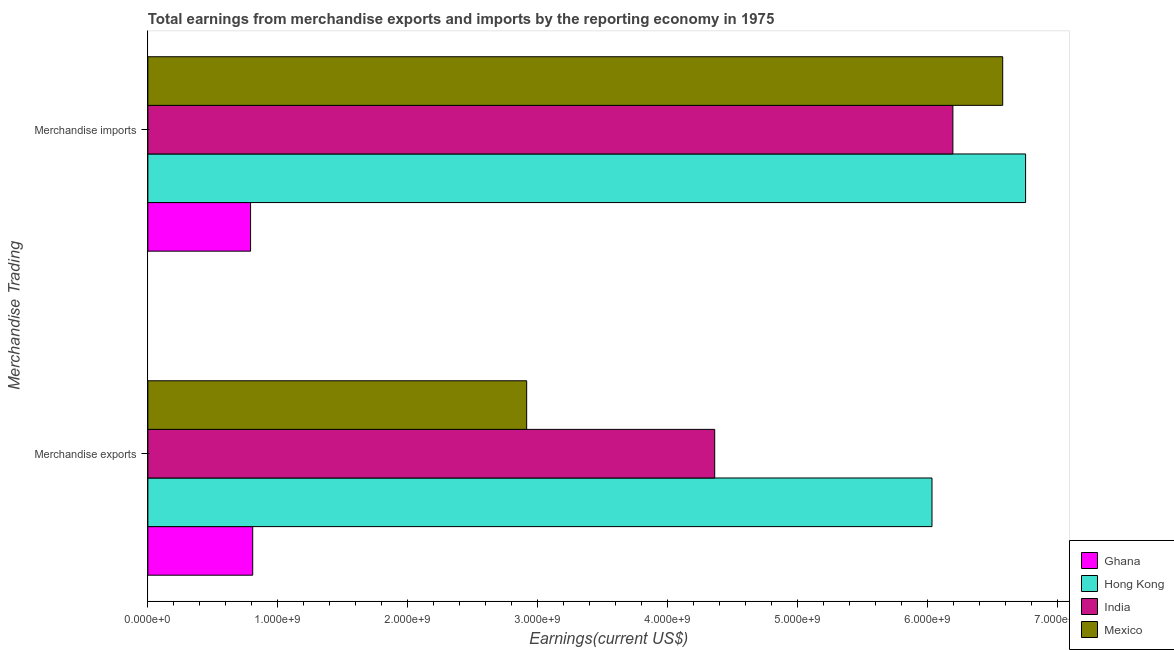How many groups of bars are there?
Make the answer very short. 2. Are the number of bars per tick equal to the number of legend labels?
Offer a terse response. Yes. Are the number of bars on each tick of the Y-axis equal?
Offer a terse response. Yes. How many bars are there on the 2nd tick from the top?
Your answer should be compact. 4. How many bars are there on the 1st tick from the bottom?
Ensure brevity in your answer.  4. What is the earnings from merchandise imports in Hong Kong?
Ensure brevity in your answer.  6.76e+09. Across all countries, what is the maximum earnings from merchandise imports?
Your response must be concise. 6.76e+09. Across all countries, what is the minimum earnings from merchandise exports?
Provide a succinct answer. 8.07e+08. In which country was the earnings from merchandise exports maximum?
Your answer should be compact. Hong Kong. What is the total earnings from merchandise imports in the graph?
Your answer should be very brief. 2.03e+1. What is the difference between the earnings from merchandise exports in Hong Kong and that in India?
Keep it short and to the point. 1.67e+09. What is the difference between the earnings from merchandise imports in Hong Kong and the earnings from merchandise exports in India?
Keep it short and to the point. 2.39e+09. What is the average earnings from merchandise exports per country?
Provide a succinct answer. 3.53e+09. What is the difference between the earnings from merchandise exports and earnings from merchandise imports in India?
Give a very brief answer. -1.83e+09. What is the ratio of the earnings from merchandise exports in Mexico to that in India?
Offer a terse response. 0.67. In how many countries, is the earnings from merchandise exports greater than the average earnings from merchandise exports taken over all countries?
Give a very brief answer. 2. What does the 1st bar from the top in Merchandise imports represents?
Offer a terse response. Mexico. What does the 1st bar from the bottom in Merchandise imports represents?
Ensure brevity in your answer.  Ghana. Are all the bars in the graph horizontal?
Your response must be concise. Yes. Does the graph contain grids?
Your answer should be compact. No. How many legend labels are there?
Ensure brevity in your answer.  4. How are the legend labels stacked?
Provide a short and direct response. Vertical. What is the title of the graph?
Provide a succinct answer. Total earnings from merchandise exports and imports by the reporting economy in 1975. Does "Middle East & North Africa (all income levels)" appear as one of the legend labels in the graph?
Ensure brevity in your answer.  No. What is the label or title of the X-axis?
Give a very brief answer. Earnings(current US$). What is the label or title of the Y-axis?
Provide a succinct answer. Merchandise Trading. What is the Earnings(current US$) in Ghana in Merchandise exports?
Your response must be concise. 8.07e+08. What is the Earnings(current US$) of Hong Kong in Merchandise exports?
Provide a succinct answer. 6.04e+09. What is the Earnings(current US$) of India in Merchandise exports?
Your response must be concise. 4.36e+09. What is the Earnings(current US$) of Mexico in Merchandise exports?
Ensure brevity in your answer.  2.92e+09. What is the Earnings(current US$) of Ghana in Merchandise imports?
Your answer should be compact. 7.91e+08. What is the Earnings(current US$) of Hong Kong in Merchandise imports?
Your answer should be compact. 6.76e+09. What is the Earnings(current US$) of India in Merchandise imports?
Provide a succinct answer. 6.20e+09. What is the Earnings(current US$) in Mexico in Merchandise imports?
Provide a short and direct response. 6.58e+09. Across all Merchandise Trading, what is the maximum Earnings(current US$) in Ghana?
Provide a succinct answer. 8.07e+08. Across all Merchandise Trading, what is the maximum Earnings(current US$) of Hong Kong?
Your answer should be very brief. 6.76e+09. Across all Merchandise Trading, what is the maximum Earnings(current US$) in India?
Keep it short and to the point. 6.20e+09. Across all Merchandise Trading, what is the maximum Earnings(current US$) in Mexico?
Your answer should be compact. 6.58e+09. Across all Merchandise Trading, what is the minimum Earnings(current US$) in Ghana?
Your answer should be compact. 7.91e+08. Across all Merchandise Trading, what is the minimum Earnings(current US$) of Hong Kong?
Make the answer very short. 6.04e+09. Across all Merchandise Trading, what is the minimum Earnings(current US$) in India?
Offer a terse response. 4.36e+09. Across all Merchandise Trading, what is the minimum Earnings(current US$) of Mexico?
Keep it short and to the point. 2.92e+09. What is the total Earnings(current US$) of Ghana in the graph?
Make the answer very short. 1.60e+09. What is the total Earnings(current US$) in Hong Kong in the graph?
Provide a short and direct response. 1.28e+1. What is the total Earnings(current US$) of India in the graph?
Your answer should be compact. 1.06e+1. What is the total Earnings(current US$) of Mexico in the graph?
Give a very brief answer. 9.50e+09. What is the difference between the Earnings(current US$) in Ghana in Merchandise exports and that in Merchandise imports?
Offer a very short reply. 1.65e+07. What is the difference between the Earnings(current US$) of Hong Kong in Merchandise exports and that in Merchandise imports?
Ensure brevity in your answer.  -7.21e+08. What is the difference between the Earnings(current US$) in India in Merchandise exports and that in Merchandise imports?
Give a very brief answer. -1.83e+09. What is the difference between the Earnings(current US$) of Mexico in Merchandise exports and that in Merchandise imports?
Your response must be concise. -3.66e+09. What is the difference between the Earnings(current US$) of Ghana in Merchandise exports and the Earnings(current US$) of Hong Kong in Merchandise imports?
Provide a succinct answer. -5.95e+09. What is the difference between the Earnings(current US$) of Ghana in Merchandise exports and the Earnings(current US$) of India in Merchandise imports?
Your response must be concise. -5.39e+09. What is the difference between the Earnings(current US$) of Ghana in Merchandise exports and the Earnings(current US$) of Mexico in Merchandise imports?
Your answer should be very brief. -5.77e+09. What is the difference between the Earnings(current US$) of Hong Kong in Merchandise exports and the Earnings(current US$) of India in Merchandise imports?
Offer a terse response. -1.61e+08. What is the difference between the Earnings(current US$) in Hong Kong in Merchandise exports and the Earnings(current US$) in Mexico in Merchandise imports?
Make the answer very short. -5.44e+08. What is the difference between the Earnings(current US$) of India in Merchandise exports and the Earnings(current US$) of Mexico in Merchandise imports?
Ensure brevity in your answer.  -2.22e+09. What is the average Earnings(current US$) in Ghana per Merchandise Trading?
Your answer should be very brief. 7.99e+08. What is the average Earnings(current US$) in Hong Kong per Merchandise Trading?
Your response must be concise. 6.40e+09. What is the average Earnings(current US$) of India per Merchandise Trading?
Provide a short and direct response. 5.28e+09. What is the average Earnings(current US$) of Mexico per Merchandise Trading?
Provide a short and direct response. 4.75e+09. What is the difference between the Earnings(current US$) in Ghana and Earnings(current US$) in Hong Kong in Merchandise exports?
Offer a very short reply. -5.23e+09. What is the difference between the Earnings(current US$) in Ghana and Earnings(current US$) in India in Merchandise exports?
Make the answer very short. -3.56e+09. What is the difference between the Earnings(current US$) in Ghana and Earnings(current US$) in Mexico in Merchandise exports?
Give a very brief answer. -2.11e+09. What is the difference between the Earnings(current US$) of Hong Kong and Earnings(current US$) of India in Merchandise exports?
Your response must be concise. 1.67e+09. What is the difference between the Earnings(current US$) of Hong Kong and Earnings(current US$) of Mexico in Merchandise exports?
Ensure brevity in your answer.  3.12e+09. What is the difference between the Earnings(current US$) of India and Earnings(current US$) of Mexico in Merchandise exports?
Your answer should be compact. 1.45e+09. What is the difference between the Earnings(current US$) of Ghana and Earnings(current US$) of Hong Kong in Merchandise imports?
Ensure brevity in your answer.  -5.97e+09. What is the difference between the Earnings(current US$) of Ghana and Earnings(current US$) of India in Merchandise imports?
Offer a terse response. -5.41e+09. What is the difference between the Earnings(current US$) of Ghana and Earnings(current US$) of Mexico in Merchandise imports?
Make the answer very short. -5.79e+09. What is the difference between the Earnings(current US$) of Hong Kong and Earnings(current US$) of India in Merchandise imports?
Ensure brevity in your answer.  5.60e+08. What is the difference between the Earnings(current US$) in Hong Kong and Earnings(current US$) in Mexico in Merchandise imports?
Ensure brevity in your answer.  1.76e+08. What is the difference between the Earnings(current US$) of India and Earnings(current US$) of Mexico in Merchandise imports?
Make the answer very short. -3.84e+08. What is the ratio of the Earnings(current US$) in Ghana in Merchandise exports to that in Merchandise imports?
Your response must be concise. 1.02. What is the ratio of the Earnings(current US$) in Hong Kong in Merchandise exports to that in Merchandise imports?
Provide a succinct answer. 0.89. What is the ratio of the Earnings(current US$) of India in Merchandise exports to that in Merchandise imports?
Offer a terse response. 0.7. What is the ratio of the Earnings(current US$) in Mexico in Merchandise exports to that in Merchandise imports?
Your answer should be compact. 0.44. What is the difference between the highest and the second highest Earnings(current US$) of Ghana?
Provide a short and direct response. 1.65e+07. What is the difference between the highest and the second highest Earnings(current US$) of Hong Kong?
Provide a short and direct response. 7.21e+08. What is the difference between the highest and the second highest Earnings(current US$) in India?
Provide a succinct answer. 1.83e+09. What is the difference between the highest and the second highest Earnings(current US$) of Mexico?
Provide a short and direct response. 3.66e+09. What is the difference between the highest and the lowest Earnings(current US$) of Ghana?
Keep it short and to the point. 1.65e+07. What is the difference between the highest and the lowest Earnings(current US$) of Hong Kong?
Your answer should be very brief. 7.21e+08. What is the difference between the highest and the lowest Earnings(current US$) of India?
Your answer should be compact. 1.83e+09. What is the difference between the highest and the lowest Earnings(current US$) of Mexico?
Keep it short and to the point. 3.66e+09. 